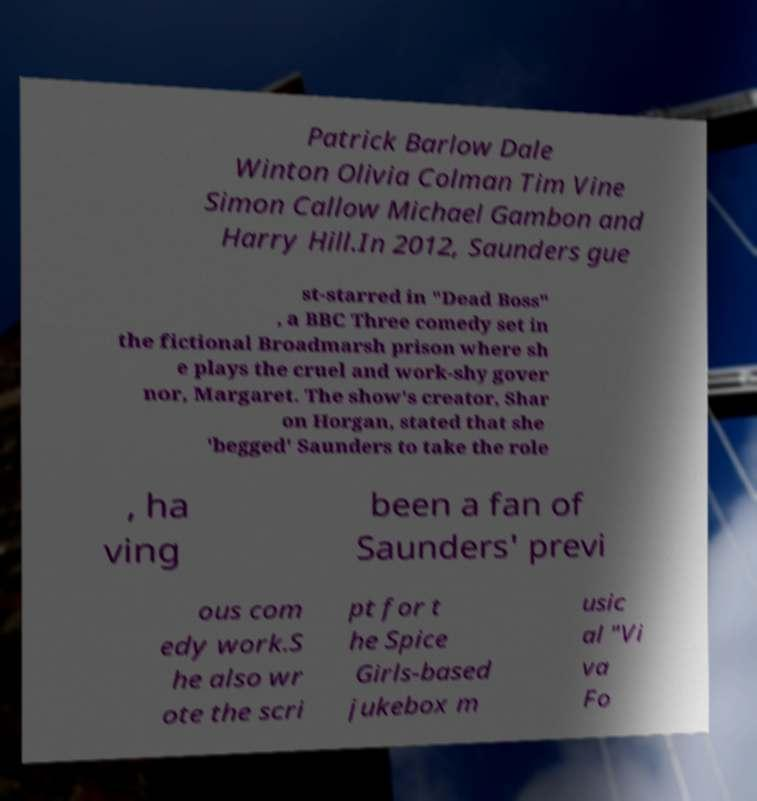Could you extract and type out the text from this image? Patrick Barlow Dale Winton Olivia Colman Tim Vine Simon Callow Michael Gambon and Harry Hill.In 2012, Saunders gue st-starred in "Dead Boss" , a BBC Three comedy set in the fictional Broadmarsh prison where sh e plays the cruel and work-shy gover nor, Margaret. The show's creator, Shar on Horgan, stated that she 'begged' Saunders to take the role , ha ving been a fan of Saunders' previ ous com edy work.S he also wr ote the scri pt for t he Spice Girls-based jukebox m usic al "Vi va Fo 